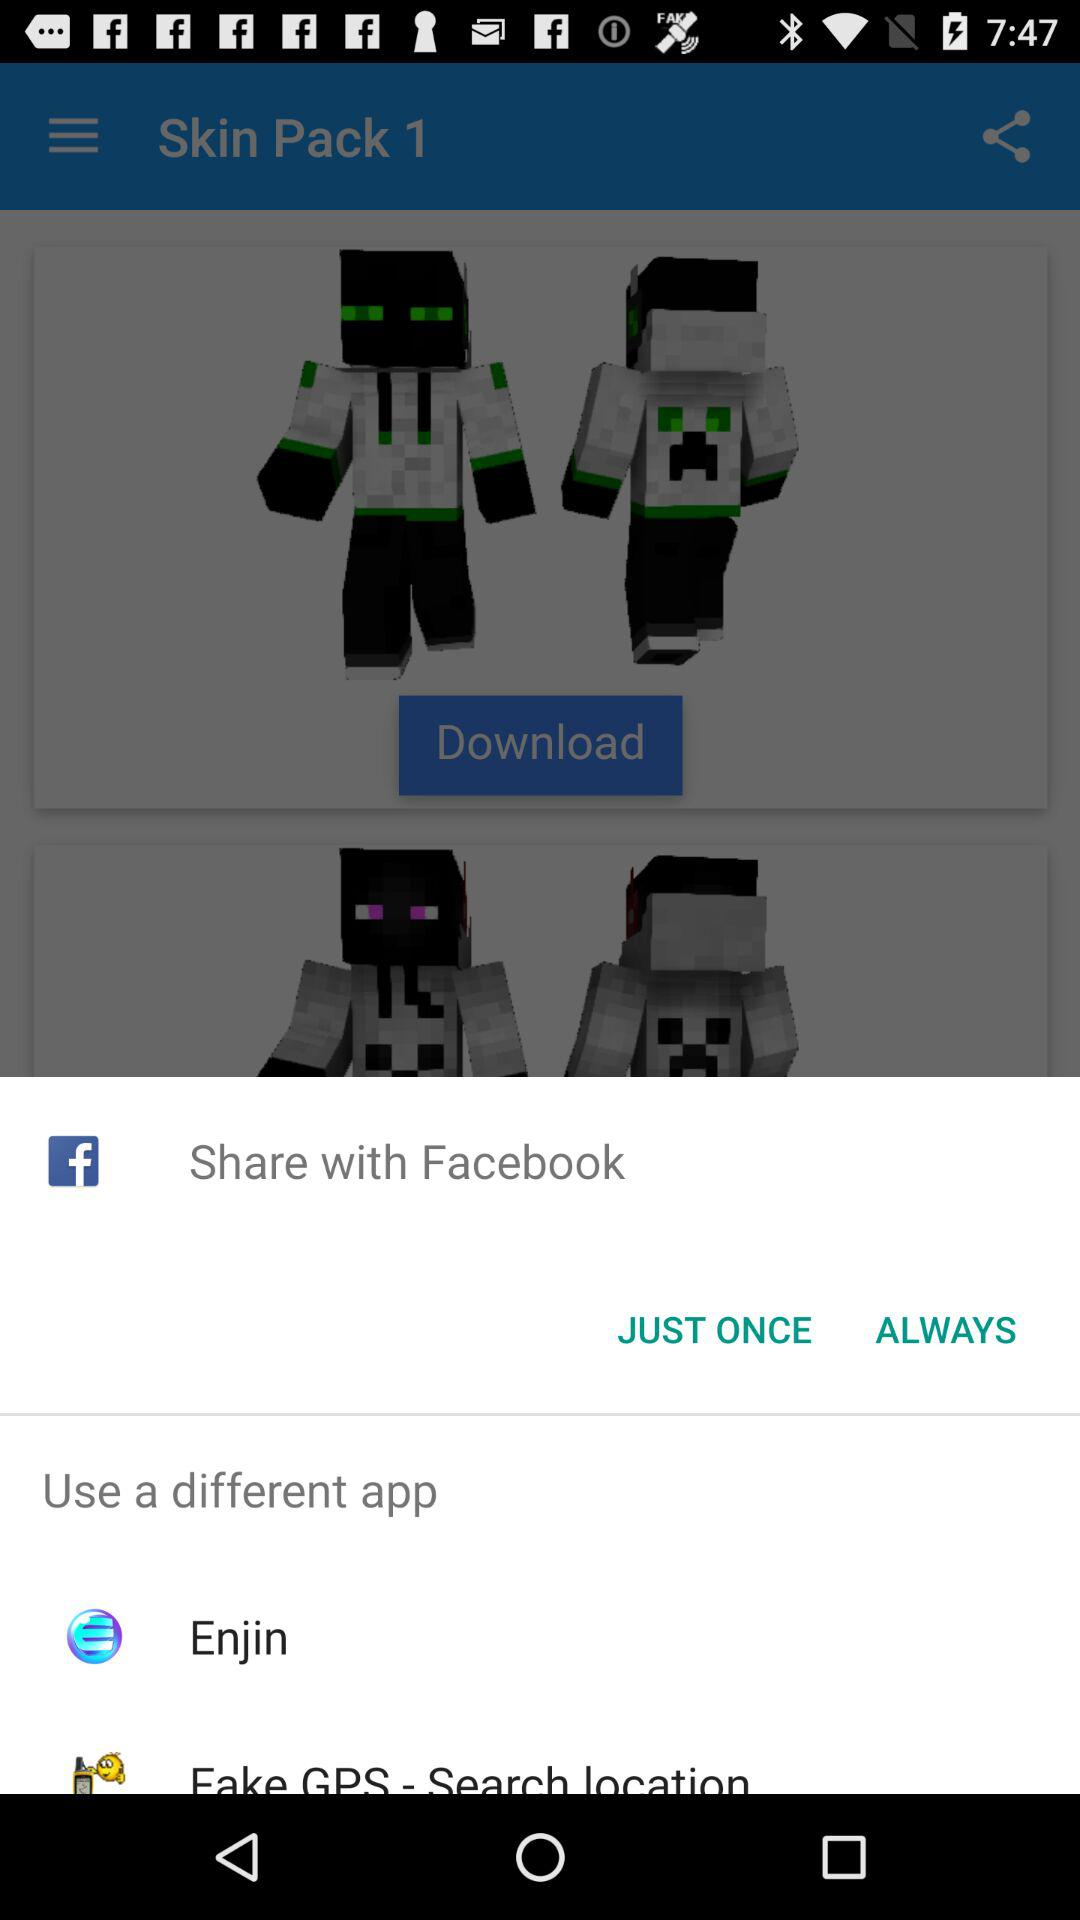Through which application can the content be shared? The content can be shared through "Facebook", "Enjin" and "Fake GPS - Search location". 